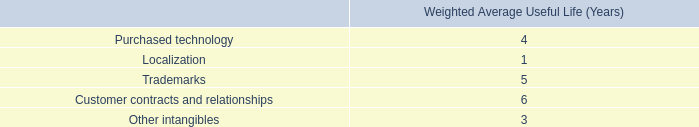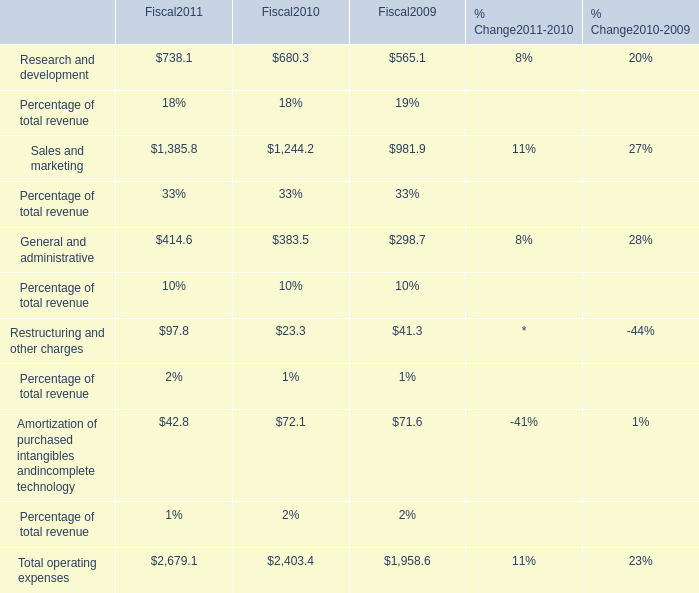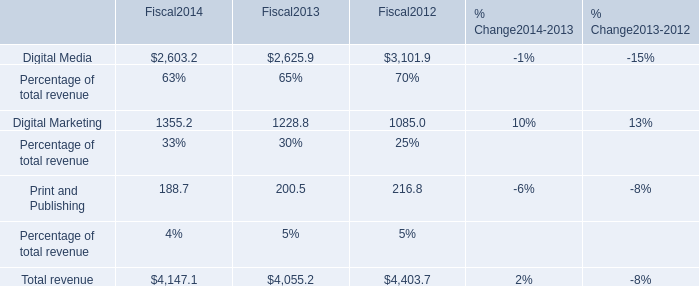What will Research and development be like in 2012 if it continues to grow at the same rate as it did in 2011? 
Computations: (738.1 * (1 + ((738.1 - 680.3) / 680.3)))
Answer: 800.81083. 